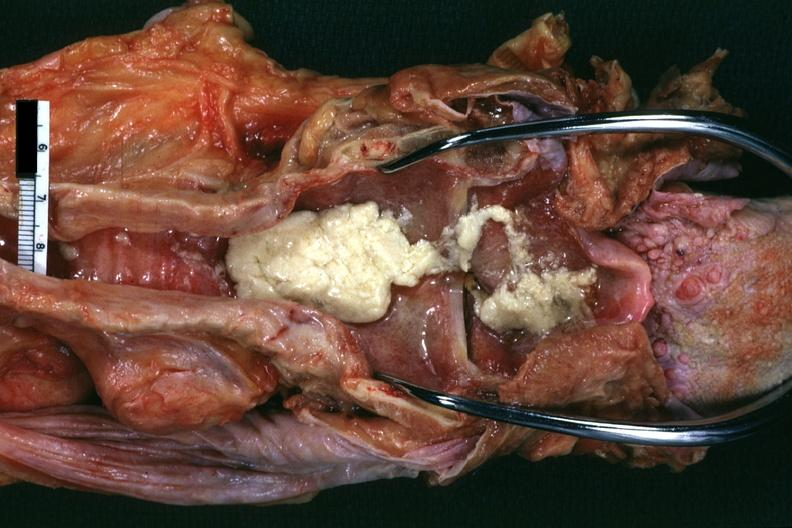does oil acid show aspirated mucus excellent?
Answer the question using a single word or phrase. No 